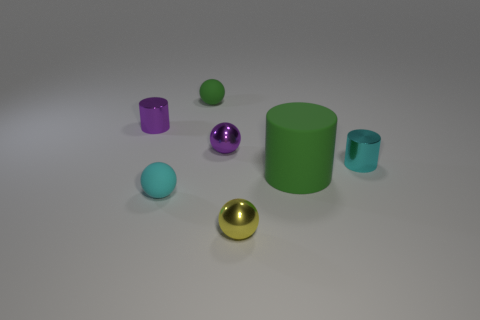There is a matte ball that is in front of the tiny cyan thing that is to the right of the tiny yellow metal object; what size is it?
Your answer should be very brief. Small. There is a big rubber object; is it the same color as the sphere that is to the left of the tiny green matte sphere?
Make the answer very short. No. There is a green thing that is the same size as the yellow metallic thing; what is its material?
Offer a very short reply. Rubber. Is the number of tiny metallic balls that are in front of the big green cylinder less than the number of small cyan cylinders that are to the right of the tiny green matte thing?
Provide a short and direct response. No. The shiny object on the left side of the small metallic sphere that is behind the tiny cyan sphere is what shape?
Offer a very short reply. Cylinder. Are any small matte balls visible?
Your answer should be very brief. Yes. There is a small metal ball behind the rubber cylinder; what color is it?
Provide a short and direct response. Purple. What material is the ball that is the same color as the big matte cylinder?
Offer a very short reply. Rubber. Are there any purple metallic spheres right of the purple sphere?
Keep it short and to the point. No. Is the number of big purple metallic blocks greater than the number of purple things?
Make the answer very short. No. 